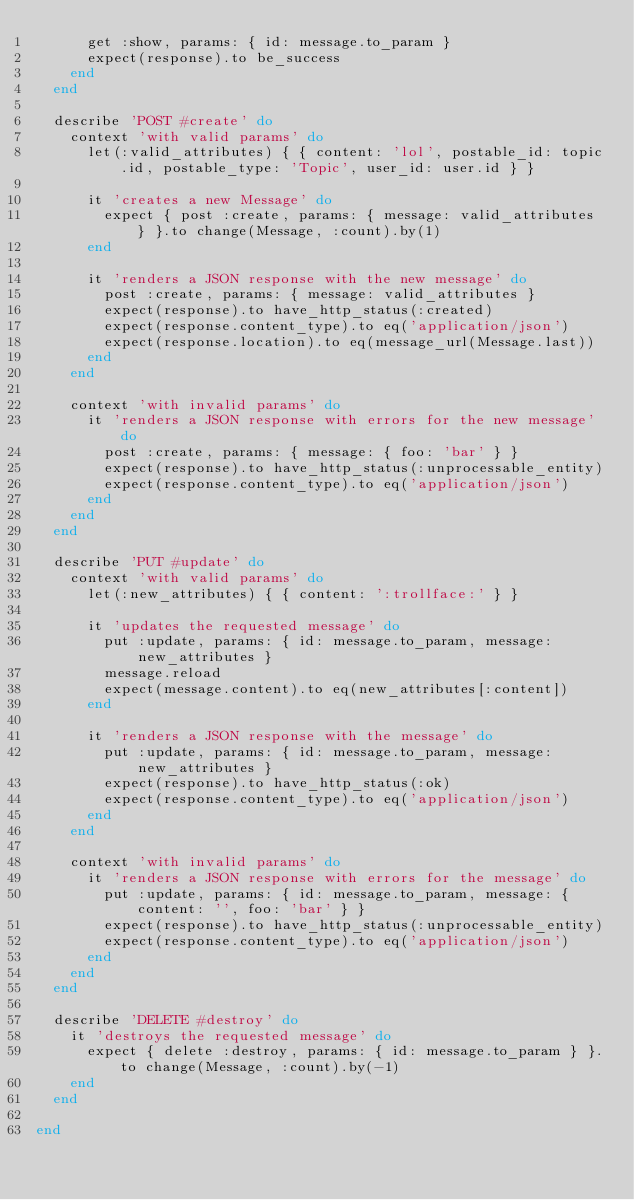<code> <loc_0><loc_0><loc_500><loc_500><_Ruby_>      get :show, params: { id: message.to_param }
      expect(response).to be_success
    end
  end

  describe 'POST #create' do
    context 'with valid params' do
      let(:valid_attributes) { { content: 'lol', postable_id: topic.id, postable_type: 'Topic', user_id: user.id } }

      it 'creates a new Message' do
        expect { post :create, params: { message: valid_attributes } }.to change(Message, :count).by(1)
      end

      it 'renders a JSON response with the new message' do
        post :create, params: { message: valid_attributes }
        expect(response).to have_http_status(:created)
        expect(response.content_type).to eq('application/json')
        expect(response.location).to eq(message_url(Message.last))
      end
    end

    context 'with invalid params' do
      it 'renders a JSON response with errors for the new message' do
        post :create, params: { message: { foo: 'bar' } }
        expect(response).to have_http_status(:unprocessable_entity)
        expect(response.content_type).to eq('application/json')
      end
    end
  end

  describe 'PUT #update' do
    context 'with valid params' do
      let(:new_attributes) { { content: ':trollface:' } }

      it 'updates the requested message' do
        put :update, params: { id: message.to_param, message: new_attributes }
        message.reload
        expect(message.content).to eq(new_attributes[:content])
      end

      it 'renders a JSON response with the message' do
        put :update, params: { id: message.to_param, message: new_attributes }
        expect(response).to have_http_status(:ok)
        expect(response.content_type).to eq('application/json')
      end
    end

    context 'with invalid params' do
      it 'renders a JSON response with errors for the message' do
        put :update, params: { id: message.to_param, message: { content: '', foo: 'bar' } }
        expect(response).to have_http_status(:unprocessable_entity)
        expect(response.content_type).to eq('application/json')
      end
    end
  end

  describe 'DELETE #destroy' do
    it 'destroys the requested message' do
      expect { delete :destroy, params: { id: message.to_param } }.to change(Message, :count).by(-1)
    end
  end

end
</code> 